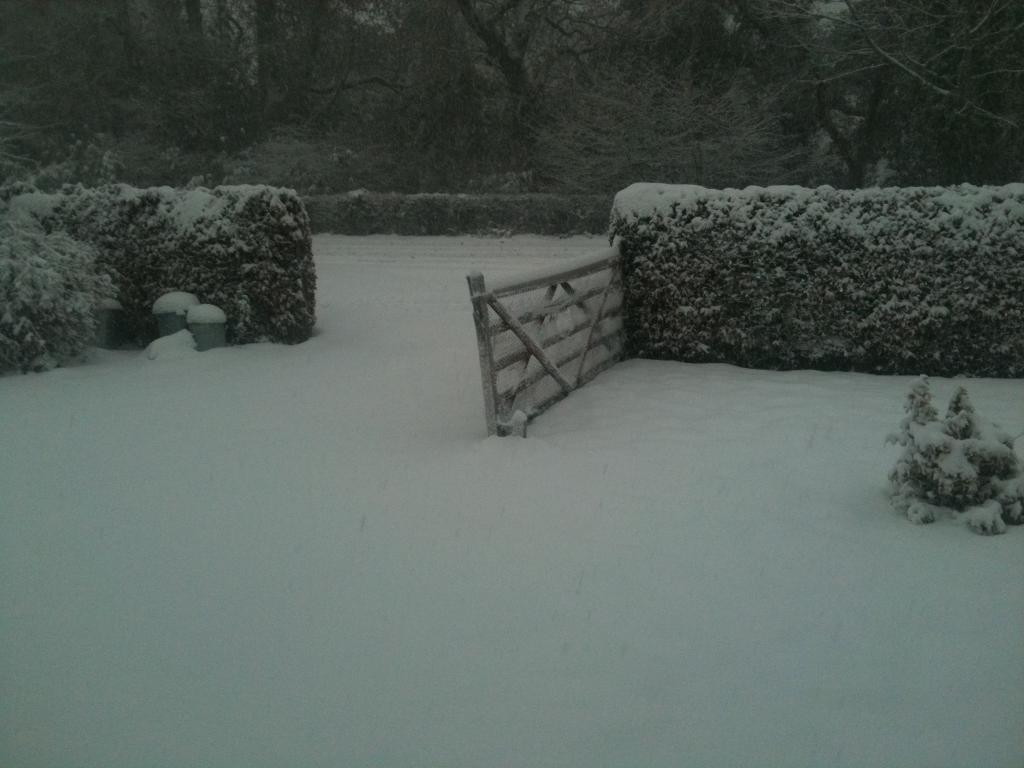Could you give a brief overview of what you see in this image? In this picture we can see snow at the bottom, there are some plants and a gate in the middle, in the background we can see trees. 